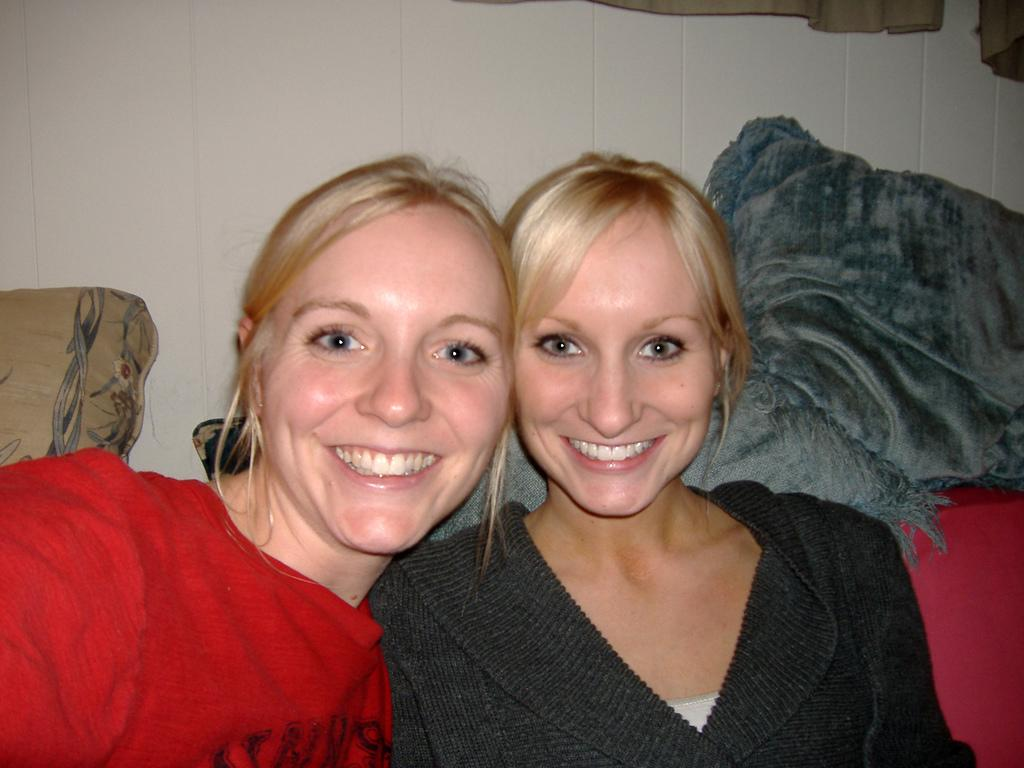How many women are in the image? There are two women in the image. What are the women doing in the image? The women are sitting together and smiling. What colors are the T-shirts worn by the women? One woman is wearing a red T-shirt, and the other woman is wearing a black T-shirt. What can be seen in the background of the image? There is a white wall in the background of the image. Reasoning: Let's think step by following the steps to produce the conversation. We start by identifying the main subjects in the image, which are the two women. Then, we describe their actions and expressions, as well as the colors of their T-shirts. Finally, we mention the background of the image, which is a white wall. Each question is designed to elicit a specific detail about the image that is known from the provided from the provided facts. Absurd Question/Answer: How many cows are present in the image? There are no cows present in the image; it features two women sitting together. What type of art can be seen hanging on the wall in the image? There is no art visible on the white wall in the background of the image. What type of art can be seen hanging on the wall in the image? There is no art visible on the white wall in the background of the image. 